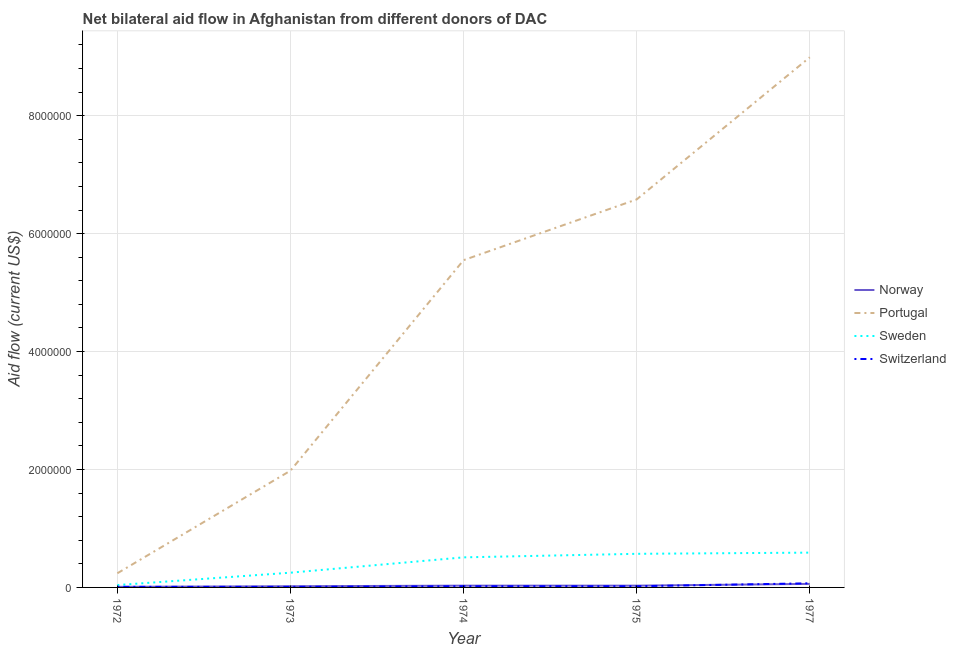How many different coloured lines are there?
Keep it short and to the point. 4. Is the number of lines equal to the number of legend labels?
Make the answer very short. Yes. What is the amount of aid given by sweden in 1975?
Make the answer very short. 5.70e+05. Across all years, what is the maximum amount of aid given by norway?
Ensure brevity in your answer.  6.00e+04. Across all years, what is the minimum amount of aid given by switzerland?
Ensure brevity in your answer.  10000. In which year was the amount of aid given by norway maximum?
Make the answer very short. 1977. What is the total amount of aid given by sweden in the graph?
Your answer should be very brief. 1.96e+06. What is the difference between the amount of aid given by sweden in 1975 and that in 1977?
Your answer should be very brief. -2.00e+04. What is the difference between the amount of aid given by sweden in 1977 and the amount of aid given by norway in 1973?
Your answer should be very brief. 5.70e+05. What is the average amount of aid given by portugal per year?
Offer a terse response. 4.67e+06. In the year 1973, what is the difference between the amount of aid given by switzerland and amount of aid given by norway?
Ensure brevity in your answer.  -10000. In how many years, is the amount of aid given by sweden greater than 400000 US$?
Keep it short and to the point. 3. What is the ratio of the amount of aid given by switzerland in 1972 to that in 1975?
Offer a terse response. 0.5. What is the difference between the highest and the lowest amount of aid given by norway?
Give a very brief answer. 5.00e+04. In how many years, is the amount of aid given by norway greater than the average amount of aid given by norway taken over all years?
Ensure brevity in your answer.  1. Does the amount of aid given by norway monotonically increase over the years?
Keep it short and to the point. No. How many lines are there?
Give a very brief answer. 4. How many years are there in the graph?
Your answer should be compact. 5. What is the difference between two consecutive major ticks on the Y-axis?
Provide a succinct answer. 2.00e+06. Does the graph contain grids?
Ensure brevity in your answer.  Yes. What is the title of the graph?
Offer a terse response. Net bilateral aid flow in Afghanistan from different donors of DAC. What is the label or title of the X-axis?
Offer a very short reply. Year. What is the Aid flow (current US$) of Norway in 1972?
Offer a terse response. 10000. What is the Aid flow (current US$) of Sweden in 1972?
Make the answer very short. 4.00e+04. What is the Aid flow (current US$) in Norway in 1973?
Your answer should be compact. 2.00e+04. What is the Aid flow (current US$) in Portugal in 1973?
Keep it short and to the point. 1.98e+06. What is the Aid flow (current US$) of Norway in 1974?
Your answer should be compact. 3.00e+04. What is the Aid flow (current US$) of Portugal in 1974?
Give a very brief answer. 5.55e+06. What is the Aid flow (current US$) of Sweden in 1974?
Your answer should be compact. 5.10e+05. What is the Aid flow (current US$) of Switzerland in 1974?
Keep it short and to the point. 2.00e+04. What is the Aid flow (current US$) in Portugal in 1975?
Keep it short and to the point. 6.58e+06. What is the Aid flow (current US$) in Sweden in 1975?
Ensure brevity in your answer.  5.70e+05. What is the Aid flow (current US$) of Switzerland in 1975?
Ensure brevity in your answer.  2.00e+04. What is the Aid flow (current US$) of Norway in 1977?
Offer a terse response. 6.00e+04. What is the Aid flow (current US$) in Portugal in 1977?
Your answer should be very brief. 8.99e+06. What is the Aid flow (current US$) of Sweden in 1977?
Provide a succinct answer. 5.90e+05. Across all years, what is the maximum Aid flow (current US$) in Norway?
Provide a short and direct response. 6.00e+04. Across all years, what is the maximum Aid flow (current US$) in Portugal?
Offer a terse response. 8.99e+06. Across all years, what is the maximum Aid flow (current US$) in Sweden?
Ensure brevity in your answer.  5.90e+05. Across all years, what is the minimum Aid flow (current US$) of Norway?
Offer a terse response. 10000. Across all years, what is the minimum Aid flow (current US$) in Portugal?
Make the answer very short. 2.40e+05. Across all years, what is the minimum Aid flow (current US$) of Sweden?
Provide a short and direct response. 4.00e+04. What is the total Aid flow (current US$) of Norway in the graph?
Your answer should be very brief. 1.50e+05. What is the total Aid flow (current US$) of Portugal in the graph?
Offer a very short reply. 2.33e+07. What is the total Aid flow (current US$) in Sweden in the graph?
Make the answer very short. 1.96e+06. What is the difference between the Aid flow (current US$) in Portugal in 1972 and that in 1973?
Your response must be concise. -1.74e+06. What is the difference between the Aid flow (current US$) of Switzerland in 1972 and that in 1973?
Offer a very short reply. 0. What is the difference between the Aid flow (current US$) of Norway in 1972 and that in 1974?
Provide a short and direct response. -2.00e+04. What is the difference between the Aid flow (current US$) of Portugal in 1972 and that in 1974?
Offer a terse response. -5.31e+06. What is the difference between the Aid flow (current US$) of Sweden in 1972 and that in 1974?
Your answer should be compact. -4.70e+05. What is the difference between the Aid flow (current US$) in Switzerland in 1972 and that in 1974?
Your response must be concise. -10000. What is the difference between the Aid flow (current US$) of Portugal in 1972 and that in 1975?
Make the answer very short. -6.34e+06. What is the difference between the Aid flow (current US$) in Sweden in 1972 and that in 1975?
Give a very brief answer. -5.30e+05. What is the difference between the Aid flow (current US$) in Switzerland in 1972 and that in 1975?
Offer a very short reply. -10000. What is the difference between the Aid flow (current US$) of Norway in 1972 and that in 1977?
Keep it short and to the point. -5.00e+04. What is the difference between the Aid flow (current US$) in Portugal in 1972 and that in 1977?
Your answer should be very brief. -8.75e+06. What is the difference between the Aid flow (current US$) in Sweden in 1972 and that in 1977?
Ensure brevity in your answer.  -5.50e+05. What is the difference between the Aid flow (current US$) of Portugal in 1973 and that in 1974?
Your response must be concise. -3.57e+06. What is the difference between the Aid flow (current US$) of Portugal in 1973 and that in 1975?
Offer a terse response. -4.60e+06. What is the difference between the Aid flow (current US$) of Sweden in 1973 and that in 1975?
Provide a succinct answer. -3.20e+05. What is the difference between the Aid flow (current US$) of Norway in 1973 and that in 1977?
Keep it short and to the point. -4.00e+04. What is the difference between the Aid flow (current US$) in Portugal in 1973 and that in 1977?
Offer a very short reply. -7.01e+06. What is the difference between the Aid flow (current US$) in Switzerland in 1973 and that in 1977?
Offer a very short reply. -6.00e+04. What is the difference between the Aid flow (current US$) in Norway in 1974 and that in 1975?
Provide a short and direct response. 0. What is the difference between the Aid flow (current US$) in Portugal in 1974 and that in 1975?
Offer a very short reply. -1.03e+06. What is the difference between the Aid flow (current US$) in Sweden in 1974 and that in 1975?
Your answer should be very brief. -6.00e+04. What is the difference between the Aid flow (current US$) in Switzerland in 1974 and that in 1975?
Ensure brevity in your answer.  0. What is the difference between the Aid flow (current US$) of Norway in 1974 and that in 1977?
Your answer should be compact. -3.00e+04. What is the difference between the Aid flow (current US$) of Portugal in 1974 and that in 1977?
Offer a terse response. -3.44e+06. What is the difference between the Aid flow (current US$) in Sweden in 1974 and that in 1977?
Ensure brevity in your answer.  -8.00e+04. What is the difference between the Aid flow (current US$) in Portugal in 1975 and that in 1977?
Ensure brevity in your answer.  -2.41e+06. What is the difference between the Aid flow (current US$) in Sweden in 1975 and that in 1977?
Provide a succinct answer. -2.00e+04. What is the difference between the Aid flow (current US$) of Norway in 1972 and the Aid flow (current US$) of Portugal in 1973?
Offer a terse response. -1.97e+06. What is the difference between the Aid flow (current US$) in Norway in 1972 and the Aid flow (current US$) in Switzerland in 1973?
Make the answer very short. 0. What is the difference between the Aid flow (current US$) of Portugal in 1972 and the Aid flow (current US$) of Switzerland in 1973?
Give a very brief answer. 2.30e+05. What is the difference between the Aid flow (current US$) in Norway in 1972 and the Aid flow (current US$) in Portugal in 1974?
Offer a terse response. -5.54e+06. What is the difference between the Aid flow (current US$) in Norway in 1972 and the Aid flow (current US$) in Sweden in 1974?
Ensure brevity in your answer.  -5.00e+05. What is the difference between the Aid flow (current US$) of Norway in 1972 and the Aid flow (current US$) of Switzerland in 1974?
Provide a succinct answer. -10000. What is the difference between the Aid flow (current US$) of Portugal in 1972 and the Aid flow (current US$) of Sweden in 1974?
Give a very brief answer. -2.70e+05. What is the difference between the Aid flow (current US$) in Sweden in 1972 and the Aid flow (current US$) in Switzerland in 1974?
Your response must be concise. 2.00e+04. What is the difference between the Aid flow (current US$) in Norway in 1972 and the Aid flow (current US$) in Portugal in 1975?
Your answer should be compact. -6.57e+06. What is the difference between the Aid flow (current US$) in Norway in 1972 and the Aid flow (current US$) in Sweden in 1975?
Your answer should be very brief. -5.60e+05. What is the difference between the Aid flow (current US$) of Norway in 1972 and the Aid flow (current US$) of Switzerland in 1975?
Your answer should be very brief. -10000. What is the difference between the Aid flow (current US$) in Portugal in 1972 and the Aid flow (current US$) in Sweden in 1975?
Keep it short and to the point. -3.30e+05. What is the difference between the Aid flow (current US$) in Portugal in 1972 and the Aid flow (current US$) in Switzerland in 1975?
Your answer should be compact. 2.20e+05. What is the difference between the Aid flow (current US$) in Sweden in 1972 and the Aid flow (current US$) in Switzerland in 1975?
Offer a very short reply. 2.00e+04. What is the difference between the Aid flow (current US$) in Norway in 1972 and the Aid flow (current US$) in Portugal in 1977?
Your answer should be compact. -8.98e+06. What is the difference between the Aid flow (current US$) of Norway in 1972 and the Aid flow (current US$) of Sweden in 1977?
Offer a terse response. -5.80e+05. What is the difference between the Aid flow (current US$) in Portugal in 1972 and the Aid flow (current US$) in Sweden in 1977?
Keep it short and to the point. -3.50e+05. What is the difference between the Aid flow (current US$) of Portugal in 1972 and the Aid flow (current US$) of Switzerland in 1977?
Provide a short and direct response. 1.70e+05. What is the difference between the Aid flow (current US$) of Norway in 1973 and the Aid flow (current US$) of Portugal in 1974?
Keep it short and to the point. -5.53e+06. What is the difference between the Aid flow (current US$) in Norway in 1973 and the Aid flow (current US$) in Sweden in 1974?
Offer a terse response. -4.90e+05. What is the difference between the Aid flow (current US$) of Norway in 1973 and the Aid flow (current US$) of Switzerland in 1974?
Make the answer very short. 0. What is the difference between the Aid flow (current US$) of Portugal in 1973 and the Aid flow (current US$) of Sweden in 1974?
Your response must be concise. 1.47e+06. What is the difference between the Aid flow (current US$) in Portugal in 1973 and the Aid flow (current US$) in Switzerland in 1974?
Your response must be concise. 1.96e+06. What is the difference between the Aid flow (current US$) of Norway in 1973 and the Aid flow (current US$) of Portugal in 1975?
Keep it short and to the point. -6.56e+06. What is the difference between the Aid flow (current US$) in Norway in 1973 and the Aid flow (current US$) in Sweden in 1975?
Provide a succinct answer. -5.50e+05. What is the difference between the Aid flow (current US$) in Portugal in 1973 and the Aid flow (current US$) in Sweden in 1975?
Provide a succinct answer. 1.41e+06. What is the difference between the Aid flow (current US$) of Portugal in 1973 and the Aid flow (current US$) of Switzerland in 1975?
Provide a short and direct response. 1.96e+06. What is the difference between the Aid flow (current US$) of Norway in 1973 and the Aid flow (current US$) of Portugal in 1977?
Provide a short and direct response. -8.97e+06. What is the difference between the Aid flow (current US$) of Norway in 1973 and the Aid flow (current US$) of Sweden in 1977?
Provide a succinct answer. -5.70e+05. What is the difference between the Aid flow (current US$) of Portugal in 1973 and the Aid flow (current US$) of Sweden in 1977?
Your answer should be very brief. 1.39e+06. What is the difference between the Aid flow (current US$) in Portugal in 1973 and the Aid flow (current US$) in Switzerland in 1977?
Your response must be concise. 1.91e+06. What is the difference between the Aid flow (current US$) of Sweden in 1973 and the Aid flow (current US$) of Switzerland in 1977?
Make the answer very short. 1.80e+05. What is the difference between the Aid flow (current US$) in Norway in 1974 and the Aid flow (current US$) in Portugal in 1975?
Provide a succinct answer. -6.55e+06. What is the difference between the Aid flow (current US$) of Norway in 1974 and the Aid flow (current US$) of Sweden in 1975?
Your response must be concise. -5.40e+05. What is the difference between the Aid flow (current US$) of Norway in 1974 and the Aid flow (current US$) of Switzerland in 1975?
Your answer should be compact. 10000. What is the difference between the Aid flow (current US$) of Portugal in 1974 and the Aid flow (current US$) of Sweden in 1975?
Keep it short and to the point. 4.98e+06. What is the difference between the Aid flow (current US$) of Portugal in 1974 and the Aid flow (current US$) of Switzerland in 1975?
Keep it short and to the point. 5.53e+06. What is the difference between the Aid flow (current US$) of Sweden in 1974 and the Aid flow (current US$) of Switzerland in 1975?
Offer a very short reply. 4.90e+05. What is the difference between the Aid flow (current US$) of Norway in 1974 and the Aid flow (current US$) of Portugal in 1977?
Give a very brief answer. -8.96e+06. What is the difference between the Aid flow (current US$) in Norway in 1974 and the Aid flow (current US$) in Sweden in 1977?
Offer a very short reply. -5.60e+05. What is the difference between the Aid flow (current US$) of Norway in 1974 and the Aid flow (current US$) of Switzerland in 1977?
Give a very brief answer. -4.00e+04. What is the difference between the Aid flow (current US$) of Portugal in 1974 and the Aid flow (current US$) of Sweden in 1977?
Your answer should be very brief. 4.96e+06. What is the difference between the Aid flow (current US$) of Portugal in 1974 and the Aid flow (current US$) of Switzerland in 1977?
Offer a terse response. 5.48e+06. What is the difference between the Aid flow (current US$) of Sweden in 1974 and the Aid flow (current US$) of Switzerland in 1977?
Provide a succinct answer. 4.40e+05. What is the difference between the Aid flow (current US$) in Norway in 1975 and the Aid flow (current US$) in Portugal in 1977?
Your answer should be compact. -8.96e+06. What is the difference between the Aid flow (current US$) of Norway in 1975 and the Aid flow (current US$) of Sweden in 1977?
Offer a very short reply. -5.60e+05. What is the difference between the Aid flow (current US$) in Norway in 1975 and the Aid flow (current US$) in Switzerland in 1977?
Give a very brief answer. -4.00e+04. What is the difference between the Aid flow (current US$) of Portugal in 1975 and the Aid flow (current US$) of Sweden in 1977?
Your answer should be compact. 5.99e+06. What is the difference between the Aid flow (current US$) in Portugal in 1975 and the Aid flow (current US$) in Switzerland in 1977?
Provide a succinct answer. 6.51e+06. What is the average Aid flow (current US$) in Norway per year?
Make the answer very short. 3.00e+04. What is the average Aid flow (current US$) in Portugal per year?
Offer a terse response. 4.67e+06. What is the average Aid flow (current US$) in Sweden per year?
Your response must be concise. 3.92e+05. What is the average Aid flow (current US$) in Switzerland per year?
Keep it short and to the point. 2.60e+04. In the year 1972, what is the difference between the Aid flow (current US$) in Norway and Aid flow (current US$) in Switzerland?
Offer a very short reply. 0. In the year 1972, what is the difference between the Aid flow (current US$) in Portugal and Aid flow (current US$) in Sweden?
Keep it short and to the point. 2.00e+05. In the year 1973, what is the difference between the Aid flow (current US$) of Norway and Aid flow (current US$) of Portugal?
Your answer should be compact. -1.96e+06. In the year 1973, what is the difference between the Aid flow (current US$) in Norway and Aid flow (current US$) in Sweden?
Provide a short and direct response. -2.30e+05. In the year 1973, what is the difference between the Aid flow (current US$) in Norway and Aid flow (current US$) in Switzerland?
Give a very brief answer. 10000. In the year 1973, what is the difference between the Aid flow (current US$) in Portugal and Aid flow (current US$) in Sweden?
Make the answer very short. 1.73e+06. In the year 1973, what is the difference between the Aid flow (current US$) in Portugal and Aid flow (current US$) in Switzerland?
Ensure brevity in your answer.  1.97e+06. In the year 1974, what is the difference between the Aid flow (current US$) in Norway and Aid flow (current US$) in Portugal?
Ensure brevity in your answer.  -5.52e+06. In the year 1974, what is the difference between the Aid flow (current US$) of Norway and Aid flow (current US$) of Sweden?
Give a very brief answer. -4.80e+05. In the year 1974, what is the difference between the Aid flow (current US$) in Norway and Aid flow (current US$) in Switzerland?
Keep it short and to the point. 10000. In the year 1974, what is the difference between the Aid flow (current US$) of Portugal and Aid flow (current US$) of Sweden?
Provide a succinct answer. 5.04e+06. In the year 1974, what is the difference between the Aid flow (current US$) in Portugal and Aid flow (current US$) in Switzerland?
Offer a very short reply. 5.53e+06. In the year 1974, what is the difference between the Aid flow (current US$) of Sweden and Aid flow (current US$) of Switzerland?
Offer a very short reply. 4.90e+05. In the year 1975, what is the difference between the Aid flow (current US$) in Norway and Aid flow (current US$) in Portugal?
Keep it short and to the point. -6.55e+06. In the year 1975, what is the difference between the Aid flow (current US$) in Norway and Aid flow (current US$) in Sweden?
Provide a succinct answer. -5.40e+05. In the year 1975, what is the difference between the Aid flow (current US$) of Norway and Aid flow (current US$) of Switzerland?
Ensure brevity in your answer.  10000. In the year 1975, what is the difference between the Aid flow (current US$) of Portugal and Aid flow (current US$) of Sweden?
Offer a very short reply. 6.01e+06. In the year 1975, what is the difference between the Aid flow (current US$) in Portugal and Aid flow (current US$) in Switzerland?
Make the answer very short. 6.56e+06. In the year 1977, what is the difference between the Aid flow (current US$) in Norway and Aid flow (current US$) in Portugal?
Ensure brevity in your answer.  -8.93e+06. In the year 1977, what is the difference between the Aid flow (current US$) of Norway and Aid flow (current US$) of Sweden?
Offer a very short reply. -5.30e+05. In the year 1977, what is the difference between the Aid flow (current US$) of Portugal and Aid flow (current US$) of Sweden?
Ensure brevity in your answer.  8.40e+06. In the year 1977, what is the difference between the Aid flow (current US$) in Portugal and Aid flow (current US$) in Switzerland?
Keep it short and to the point. 8.92e+06. In the year 1977, what is the difference between the Aid flow (current US$) of Sweden and Aid flow (current US$) of Switzerland?
Offer a very short reply. 5.20e+05. What is the ratio of the Aid flow (current US$) in Portugal in 1972 to that in 1973?
Your answer should be compact. 0.12. What is the ratio of the Aid flow (current US$) of Sweden in 1972 to that in 1973?
Provide a short and direct response. 0.16. What is the ratio of the Aid flow (current US$) of Norway in 1972 to that in 1974?
Your answer should be compact. 0.33. What is the ratio of the Aid flow (current US$) in Portugal in 1972 to that in 1974?
Offer a very short reply. 0.04. What is the ratio of the Aid flow (current US$) in Sweden in 1972 to that in 1974?
Provide a short and direct response. 0.08. What is the ratio of the Aid flow (current US$) in Switzerland in 1972 to that in 1974?
Offer a terse response. 0.5. What is the ratio of the Aid flow (current US$) in Norway in 1972 to that in 1975?
Make the answer very short. 0.33. What is the ratio of the Aid flow (current US$) in Portugal in 1972 to that in 1975?
Ensure brevity in your answer.  0.04. What is the ratio of the Aid flow (current US$) in Sweden in 1972 to that in 1975?
Provide a short and direct response. 0.07. What is the ratio of the Aid flow (current US$) in Norway in 1972 to that in 1977?
Ensure brevity in your answer.  0.17. What is the ratio of the Aid flow (current US$) of Portugal in 1972 to that in 1977?
Keep it short and to the point. 0.03. What is the ratio of the Aid flow (current US$) in Sweden in 1972 to that in 1977?
Offer a very short reply. 0.07. What is the ratio of the Aid flow (current US$) of Switzerland in 1972 to that in 1977?
Give a very brief answer. 0.14. What is the ratio of the Aid flow (current US$) of Portugal in 1973 to that in 1974?
Give a very brief answer. 0.36. What is the ratio of the Aid flow (current US$) of Sweden in 1973 to that in 1974?
Give a very brief answer. 0.49. What is the ratio of the Aid flow (current US$) of Portugal in 1973 to that in 1975?
Offer a terse response. 0.3. What is the ratio of the Aid flow (current US$) in Sweden in 1973 to that in 1975?
Provide a short and direct response. 0.44. What is the ratio of the Aid flow (current US$) of Portugal in 1973 to that in 1977?
Ensure brevity in your answer.  0.22. What is the ratio of the Aid flow (current US$) in Sweden in 1973 to that in 1977?
Your answer should be compact. 0.42. What is the ratio of the Aid flow (current US$) of Switzerland in 1973 to that in 1977?
Ensure brevity in your answer.  0.14. What is the ratio of the Aid flow (current US$) in Portugal in 1974 to that in 1975?
Your response must be concise. 0.84. What is the ratio of the Aid flow (current US$) in Sweden in 1974 to that in 1975?
Give a very brief answer. 0.89. What is the ratio of the Aid flow (current US$) in Switzerland in 1974 to that in 1975?
Offer a very short reply. 1. What is the ratio of the Aid flow (current US$) of Portugal in 1974 to that in 1977?
Your response must be concise. 0.62. What is the ratio of the Aid flow (current US$) of Sweden in 1974 to that in 1977?
Provide a succinct answer. 0.86. What is the ratio of the Aid flow (current US$) of Switzerland in 1974 to that in 1977?
Provide a short and direct response. 0.29. What is the ratio of the Aid flow (current US$) of Norway in 1975 to that in 1977?
Offer a terse response. 0.5. What is the ratio of the Aid flow (current US$) in Portugal in 1975 to that in 1977?
Give a very brief answer. 0.73. What is the ratio of the Aid flow (current US$) in Sweden in 1975 to that in 1977?
Your answer should be compact. 0.97. What is the ratio of the Aid flow (current US$) in Switzerland in 1975 to that in 1977?
Offer a very short reply. 0.29. What is the difference between the highest and the second highest Aid flow (current US$) in Portugal?
Your response must be concise. 2.41e+06. What is the difference between the highest and the second highest Aid flow (current US$) in Sweden?
Give a very brief answer. 2.00e+04. What is the difference between the highest and the lowest Aid flow (current US$) of Norway?
Give a very brief answer. 5.00e+04. What is the difference between the highest and the lowest Aid flow (current US$) in Portugal?
Ensure brevity in your answer.  8.75e+06. What is the difference between the highest and the lowest Aid flow (current US$) in Switzerland?
Offer a very short reply. 6.00e+04. 